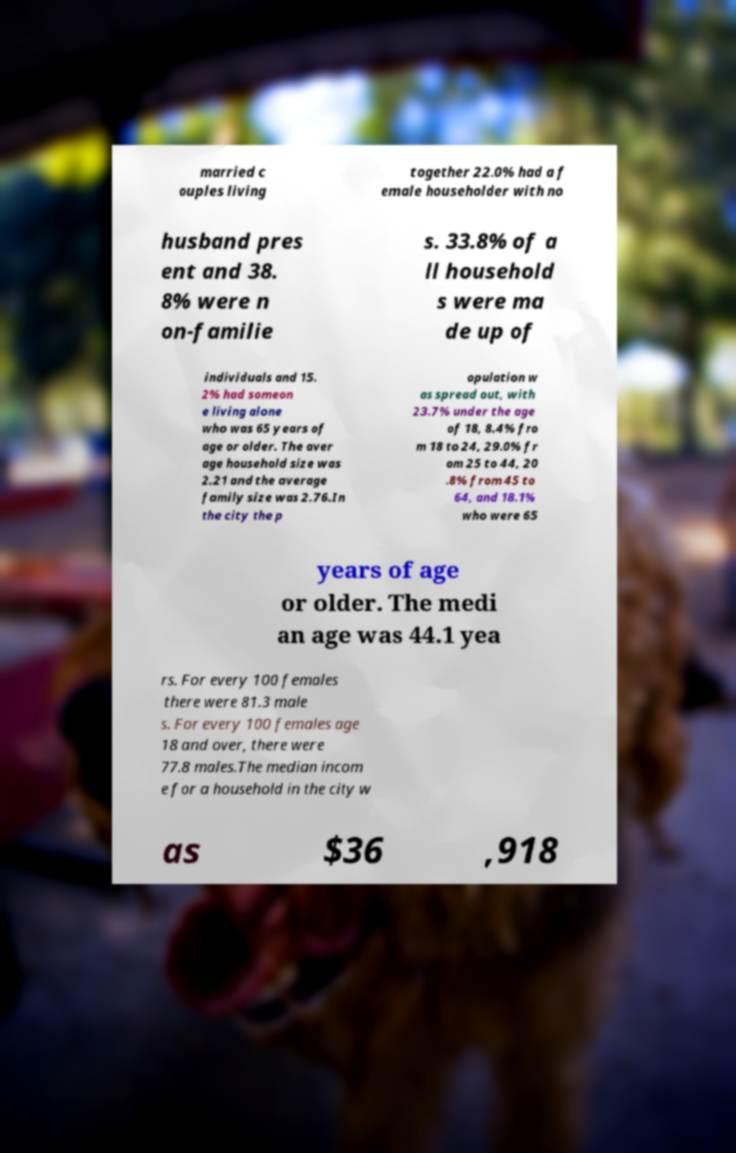Can you read and provide the text displayed in the image?This photo seems to have some interesting text. Can you extract and type it out for me? married c ouples living together 22.0% had a f emale householder with no husband pres ent and 38. 8% were n on-familie s. 33.8% of a ll household s were ma de up of individuals and 15. 2% had someon e living alone who was 65 years of age or older. The aver age household size was 2.21 and the average family size was 2.76.In the city the p opulation w as spread out, with 23.7% under the age of 18, 8.4% fro m 18 to 24, 29.0% fr om 25 to 44, 20 .8% from 45 to 64, and 18.1% who were 65 years of age or older. The medi an age was 44.1 yea rs. For every 100 females there were 81.3 male s. For every 100 females age 18 and over, there were 77.8 males.The median incom e for a household in the city w as $36 ,918 